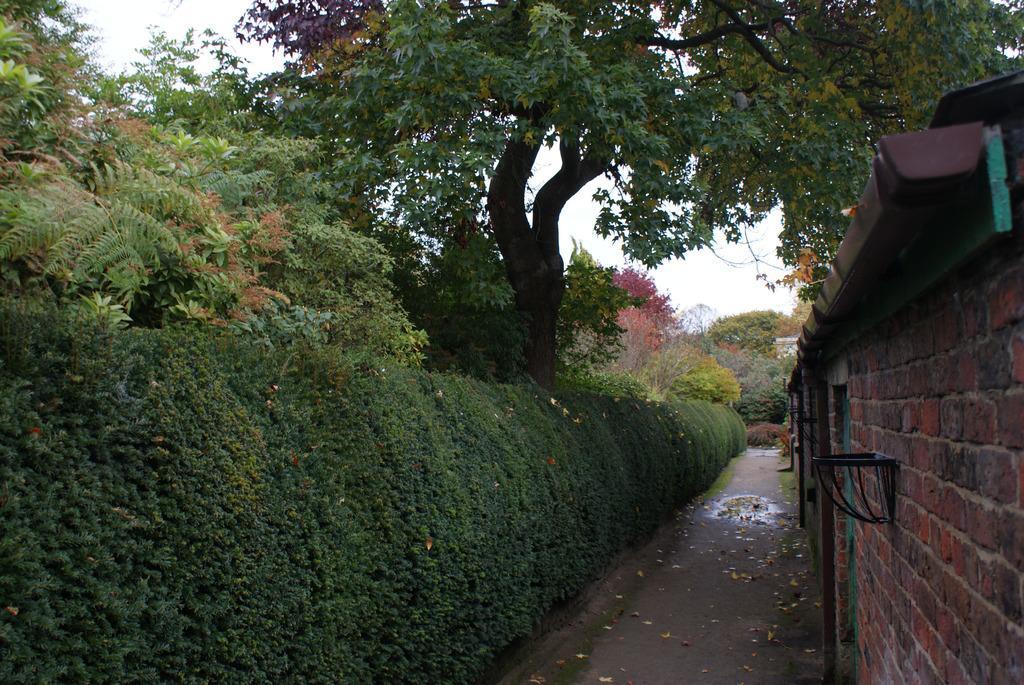How would you summarize this image in a sentence or two? In this picture, we can see houses and some objects attached to it, path, plants, trees and the sky. 